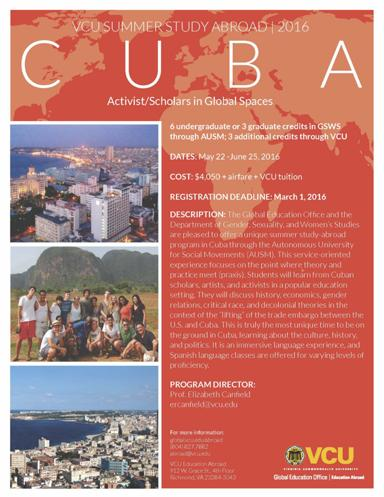What topics will students engage in during this program? Students enrolled in the 'VCU Summer Study Abroad 2016' program will explore a comprehensive curriculum that includes vital topics such as history, economics, gender relations, critical race and decolonial theories. These discussions will be framed within the context of Cuba’s evolving relationship with the U.S., particularly focusing on the implications of lifting the trade embargo. 